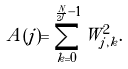Convert formula to latex. <formula><loc_0><loc_0><loc_500><loc_500>A ( j ) = \sum _ { k = 0 } ^ { \frac { N } { 2 ^ { j } } - 1 } W _ { j , k } ^ { 2 } .</formula> 